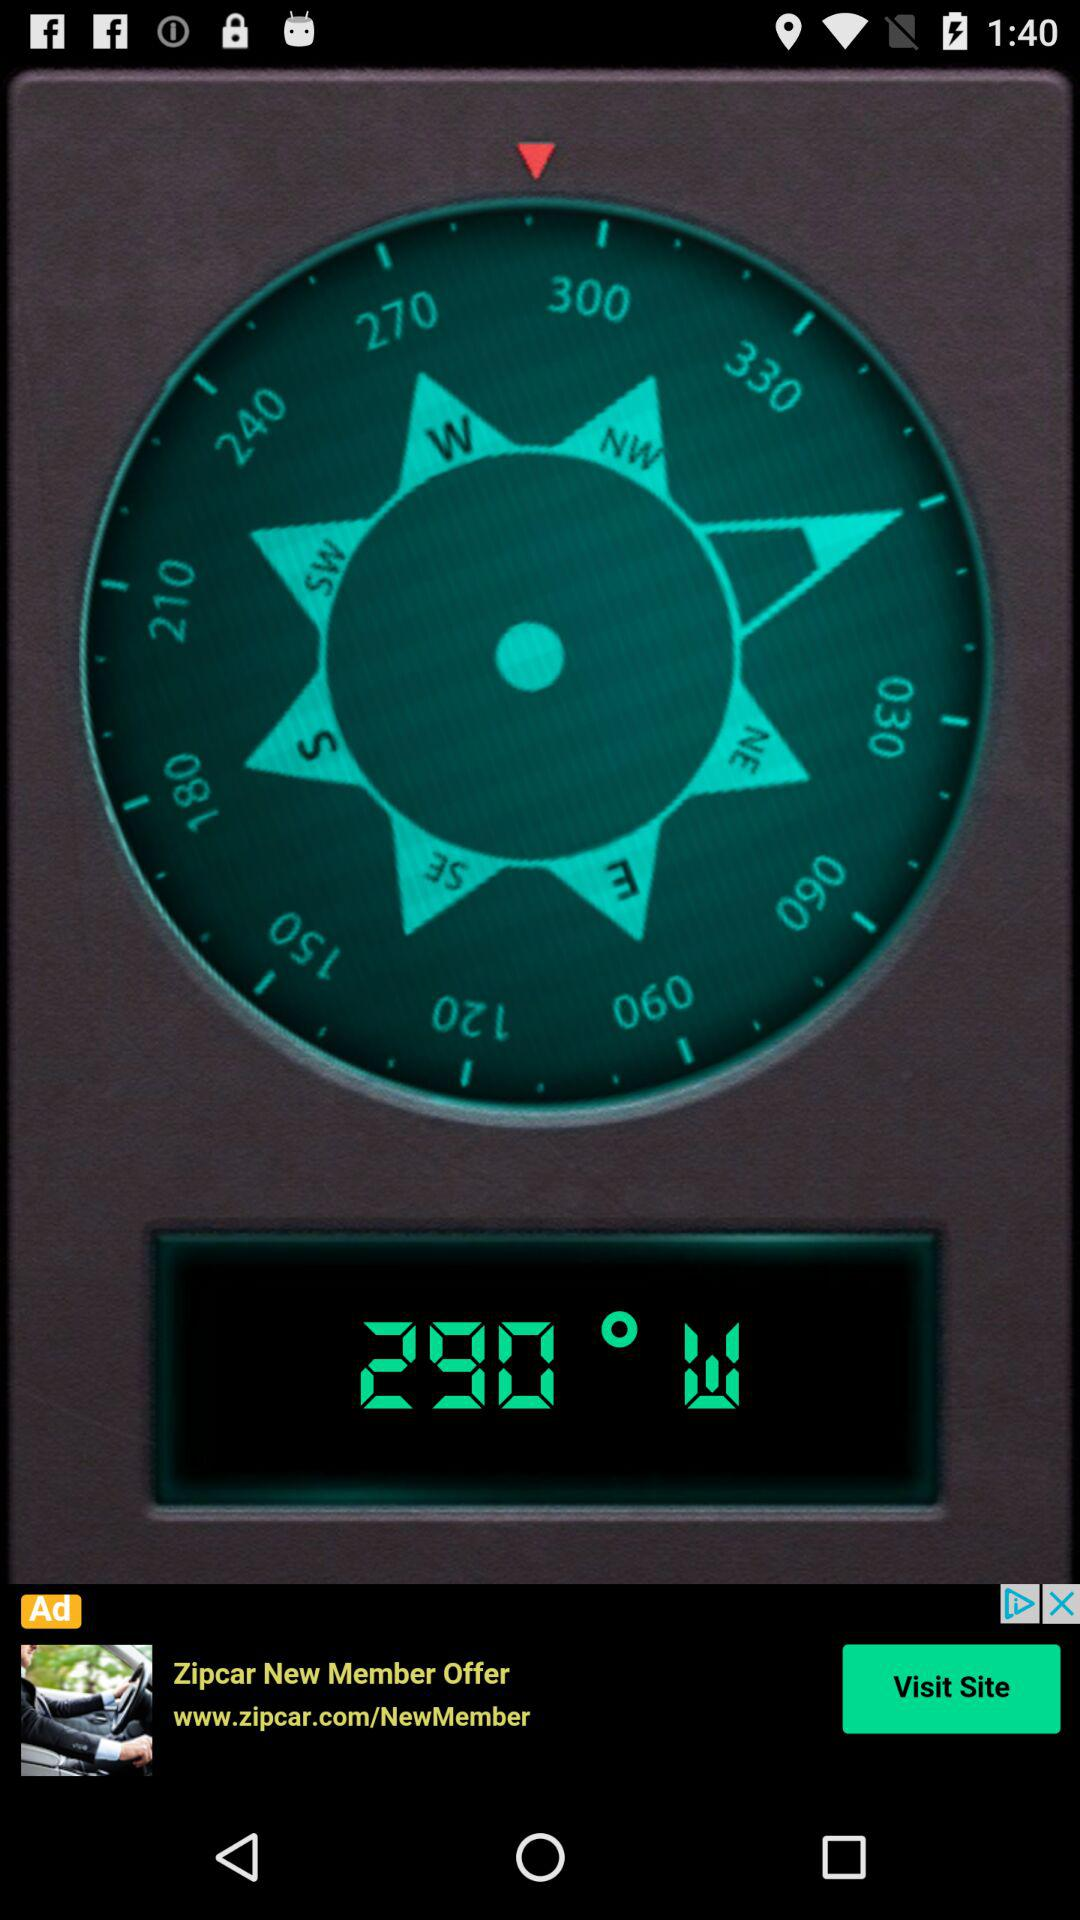What is the direction of the angle? The direction of the angle is west. 